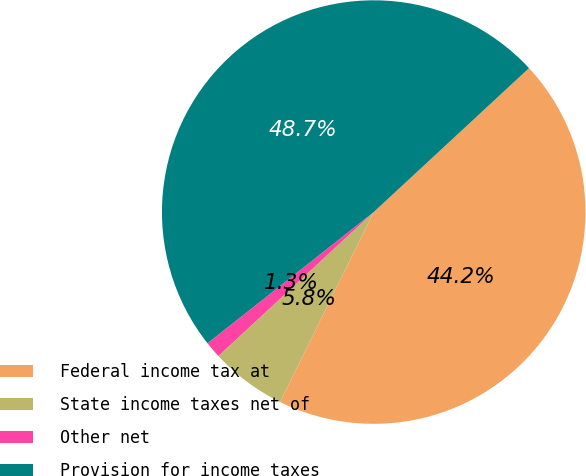Convert chart to OTSL. <chart><loc_0><loc_0><loc_500><loc_500><pie_chart><fcel>Federal income tax at<fcel>State income taxes net of<fcel>Other net<fcel>Provision for income taxes<nl><fcel>44.19%<fcel>5.81%<fcel>1.26%<fcel>48.74%<nl></chart> 